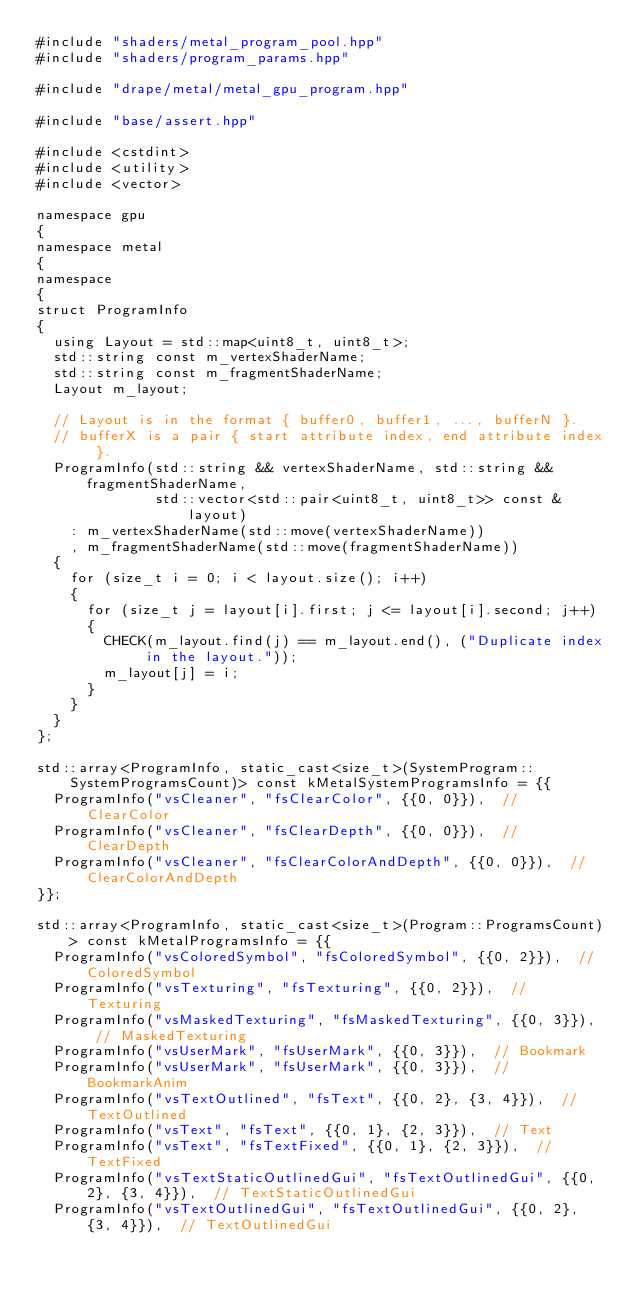Convert code to text. <code><loc_0><loc_0><loc_500><loc_500><_ObjectiveC_>#include "shaders/metal_program_pool.hpp"
#include "shaders/program_params.hpp"

#include "drape/metal/metal_gpu_program.hpp"

#include "base/assert.hpp"

#include <cstdint>
#include <utility>
#include <vector>

namespace gpu
{
namespace metal
{
namespace
{
struct ProgramInfo
{
  using Layout = std::map<uint8_t, uint8_t>;
  std::string const m_vertexShaderName;
  std::string const m_fragmentShaderName;
  Layout m_layout;
  
  // Layout is in the format { buffer0, buffer1, ..., bufferN }.
  // bufferX is a pair { start attribute index, end attribute index }.
  ProgramInfo(std::string && vertexShaderName, std::string && fragmentShaderName,
              std::vector<std::pair<uint8_t, uint8_t>> const & layout)
    : m_vertexShaderName(std::move(vertexShaderName))
    , m_fragmentShaderName(std::move(fragmentShaderName))
  {
    for (size_t i = 0; i < layout.size(); i++)
    {
      for (size_t j = layout[i].first; j <= layout[i].second; j++)
      {
        CHECK(m_layout.find(j) == m_layout.end(), ("Duplicate index in the layout."));
        m_layout[j] = i;
      }
    }
  }
};
  
std::array<ProgramInfo, static_cast<size_t>(SystemProgram::SystemProgramsCount)> const kMetalSystemProgramsInfo = {{
  ProgramInfo("vsCleaner", "fsClearColor", {{0, 0}}),  // ClearColor
  ProgramInfo("vsCleaner", "fsClearDepth", {{0, 0}}),  // ClearDepth
  ProgramInfo("vsCleaner", "fsClearColorAndDepth", {{0, 0}}),  // ClearColorAndDepth
}};
  
std::array<ProgramInfo, static_cast<size_t>(Program::ProgramsCount)> const kMetalProgramsInfo = {{
  ProgramInfo("vsColoredSymbol", "fsColoredSymbol", {{0, 2}}),  // ColoredSymbol
  ProgramInfo("vsTexturing", "fsTexturing", {{0, 2}}),  // Texturing
  ProgramInfo("vsMaskedTexturing", "fsMaskedTexturing", {{0, 3}}),  // MaskedTexturing
  ProgramInfo("vsUserMark", "fsUserMark", {{0, 3}}),  // Bookmark
  ProgramInfo("vsUserMark", "fsUserMark", {{0, 3}}),  // BookmarkAnim
  ProgramInfo("vsTextOutlined", "fsText", {{0, 2}, {3, 4}}),  // TextOutlined
  ProgramInfo("vsText", "fsText", {{0, 1}, {2, 3}}),  // Text
  ProgramInfo("vsText", "fsTextFixed", {{0, 1}, {2, 3}}),  // TextFixed
  ProgramInfo("vsTextStaticOutlinedGui", "fsTextOutlinedGui", {{0, 2}, {3, 4}}),  // TextStaticOutlinedGui
  ProgramInfo("vsTextOutlinedGui", "fsTextOutlinedGui", {{0, 2}, {3, 4}}),  // TextOutlinedGui</code> 